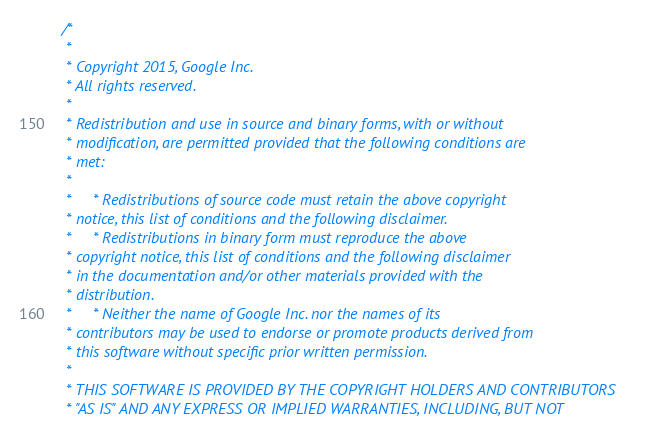<code> <loc_0><loc_0><loc_500><loc_500><_C_>/*
 *
 * Copyright 2015, Google Inc.
 * All rights reserved.
 *
 * Redistribution and use in source and binary forms, with or without
 * modification, are permitted provided that the following conditions are
 * met:
 *
 *     * Redistributions of source code must retain the above copyright
 * notice, this list of conditions and the following disclaimer.
 *     * Redistributions in binary form must reproduce the above
 * copyright notice, this list of conditions and the following disclaimer
 * in the documentation and/or other materials provided with the
 * distribution.
 *     * Neither the name of Google Inc. nor the names of its
 * contributors may be used to endorse or promote products derived from
 * this software without specific prior written permission.
 *
 * THIS SOFTWARE IS PROVIDED BY THE COPYRIGHT HOLDERS AND CONTRIBUTORS
 * "AS IS" AND ANY EXPRESS OR IMPLIED WARRANTIES, INCLUDING, BUT NOT</code> 